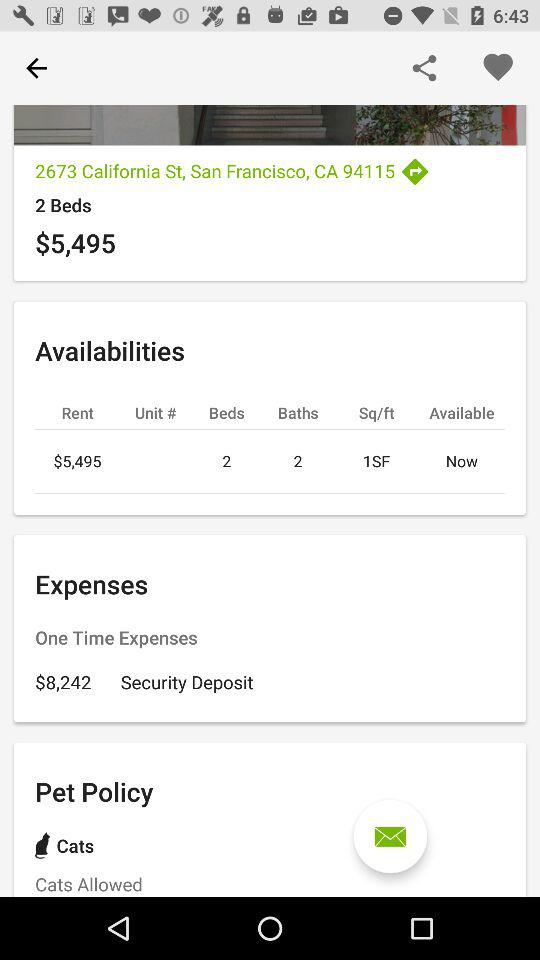How many beds are available there? There are 2 beds available. 